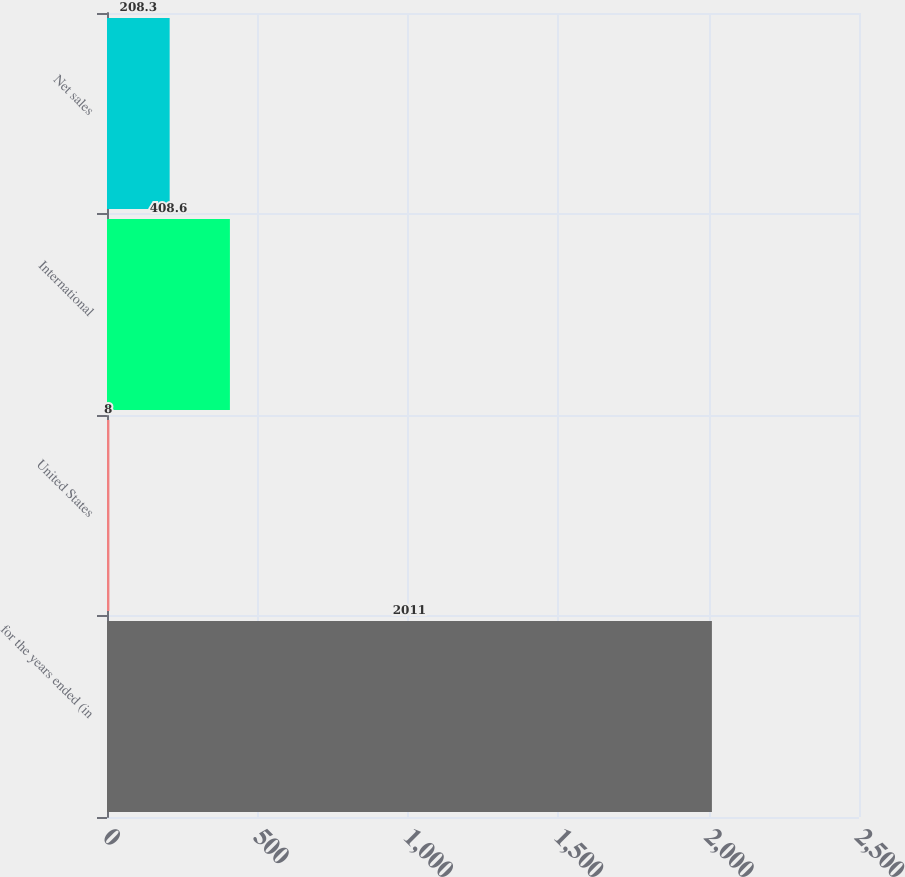Convert chart to OTSL. <chart><loc_0><loc_0><loc_500><loc_500><bar_chart><fcel>for the years ended (in<fcel>United States<fcel>International<fcel>Net sales<nl><fcel>2011<fcel>8<fcel>408.6<fcel>208.3<nl></chart> 